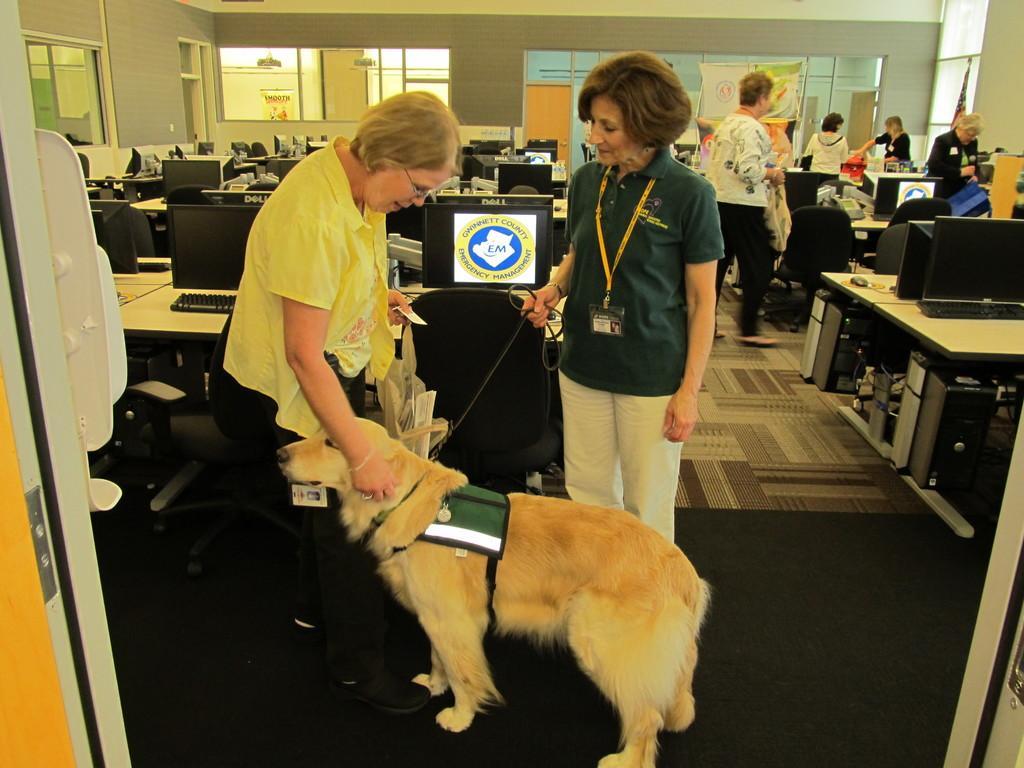Could you give a brief overview of what you see in this image? In this image I can see number of people and a dog. I can also see computers on every table. 